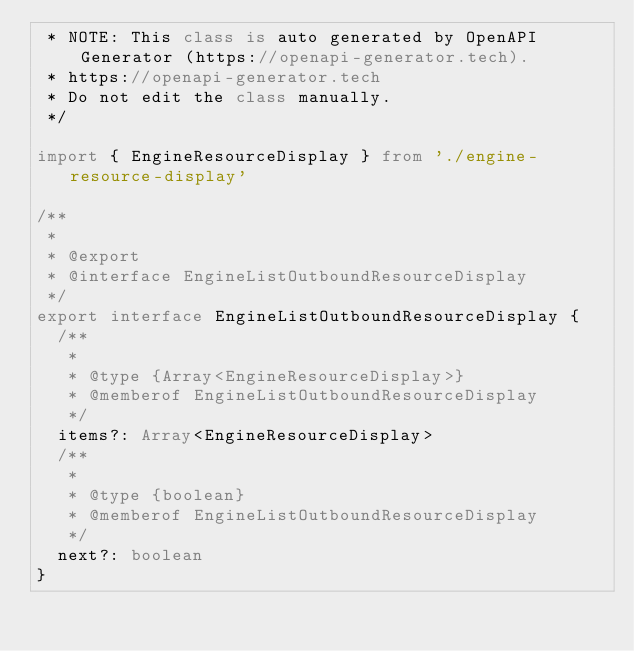<code> <loc_0><loc_0><loc_500><loc_500><_TypeScript_> * NOTE: This class is auto generated by OpenAPI Generator (https://openapi-generator.tech).
 * https://openapi-generator.tech
 * Do not edit the class manually.
 */

import { EngineResourceDisplay } from './engine-resource-display'

/**
 *
 * @export
 * @interface EngineListOutboundResourceDisplay
 */
export interface EngineListOutboundResourceDisplay {
  /**
   *
   * @type {Array<EngineResourceDisplay>}
   * @memberof EngineListOutboundResourceDisplay
   */
  items?: Array<EngineResourceDisplay>
  /**
   *
   * @type {boolean}
   * @memberof EngineListOutboundResourceDisplay
   */
  next?: boolean
}
</code> 